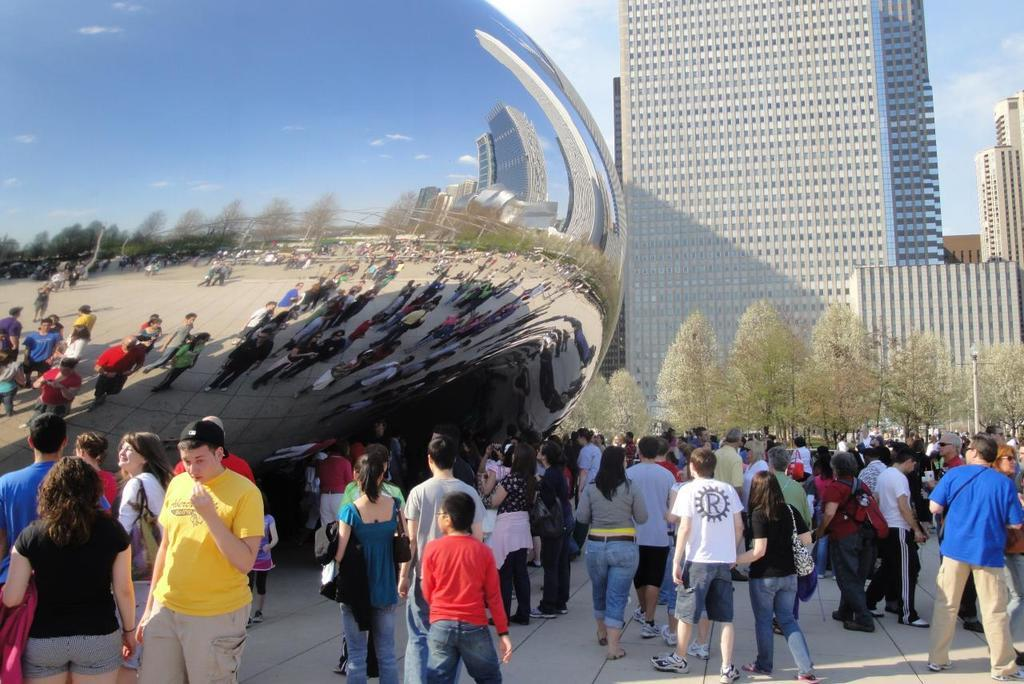What are the persons in the image doing? There are persons walking and standing in the image. What can be seen in the background of the image? There are trees, buildings, and a clear sky visible in the background of the image. Can you tell me how many crayons are on the table in the image? There is no table or crayons visible in the image. What type of animal can be seen walking with the persons in the image? There are no animals visible in the image; only persons are walking and standing. 